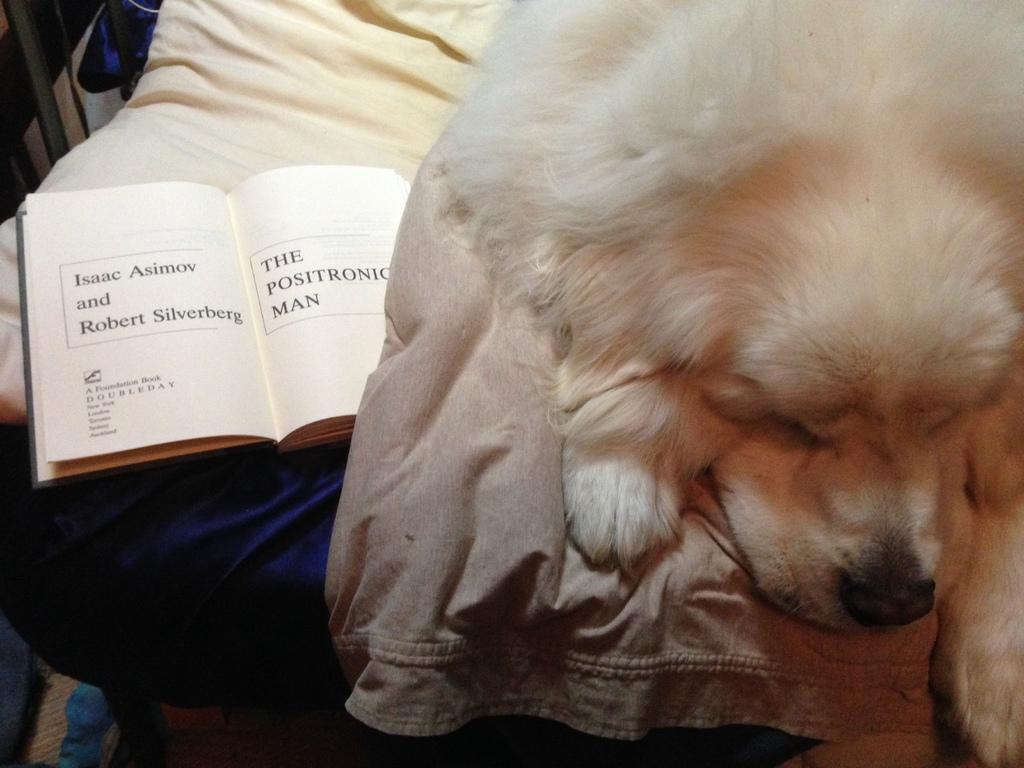What type of animal can be seen in the image? There is a dog in the image. What is on the bed in the image? There is cloth and a book on the bed. Can you describe any other objects in the image? There are other objects in the image, but their specific details are not mentioned in the provided facts. How many feet are visible in the image? There is no mention of feet in the image, so it is not possible to determine how many are visible. 